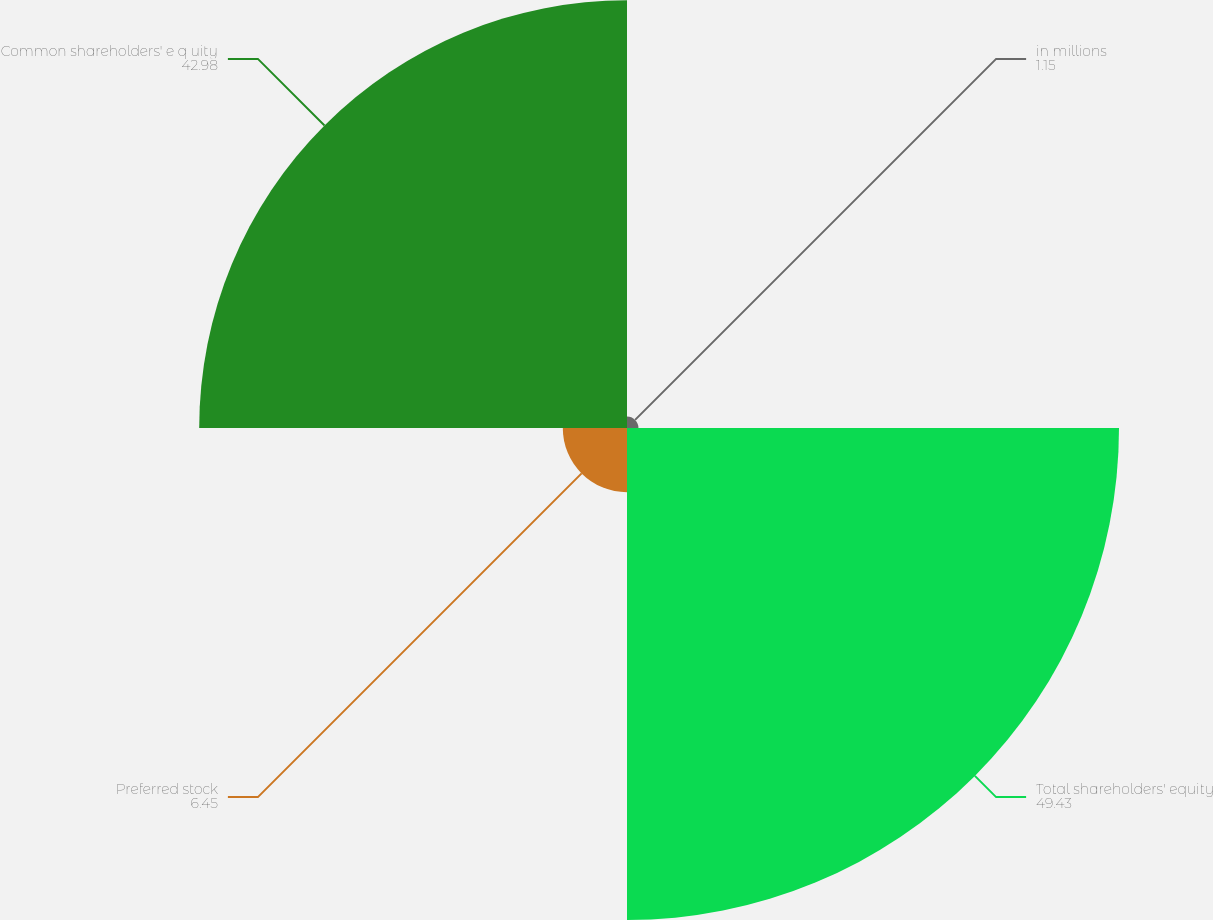<chart> <loc_0><loc_0><loc_500><loc_500><pie_chart><fcel>in millions<fcel>Total shareholders' equity<fcel>Preferred stock<fcel>Common shareholders' e q uity<nl><fcel>1.15%<fcel>49.43%<fcel>6.45%<fcel>42.98%<nl></chart> 